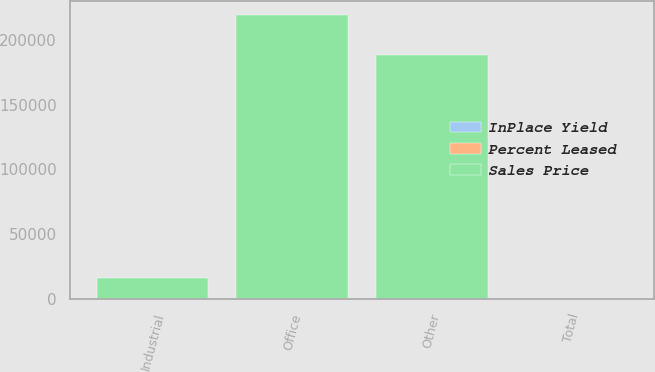<chart> <loc_0><loc_0><loc_500><loc_500><stacked_bar_chart><ecel><fcel>Industrial<fcel>Office<fcel>Other<fcel>Total<nl><fcel>Sales Price<fcel>16499<fcel>219254<fcel>188000<fcel>86.8<nl><fcel>InPlace Yield<fcel>6.3<fcel>8.3<fcel>5<fcel>6.6<nl><fcel>Percent Leased<fcel>50.1<fcel>91.8<fcel>89.8<fcel>86.8<nl></chart> 